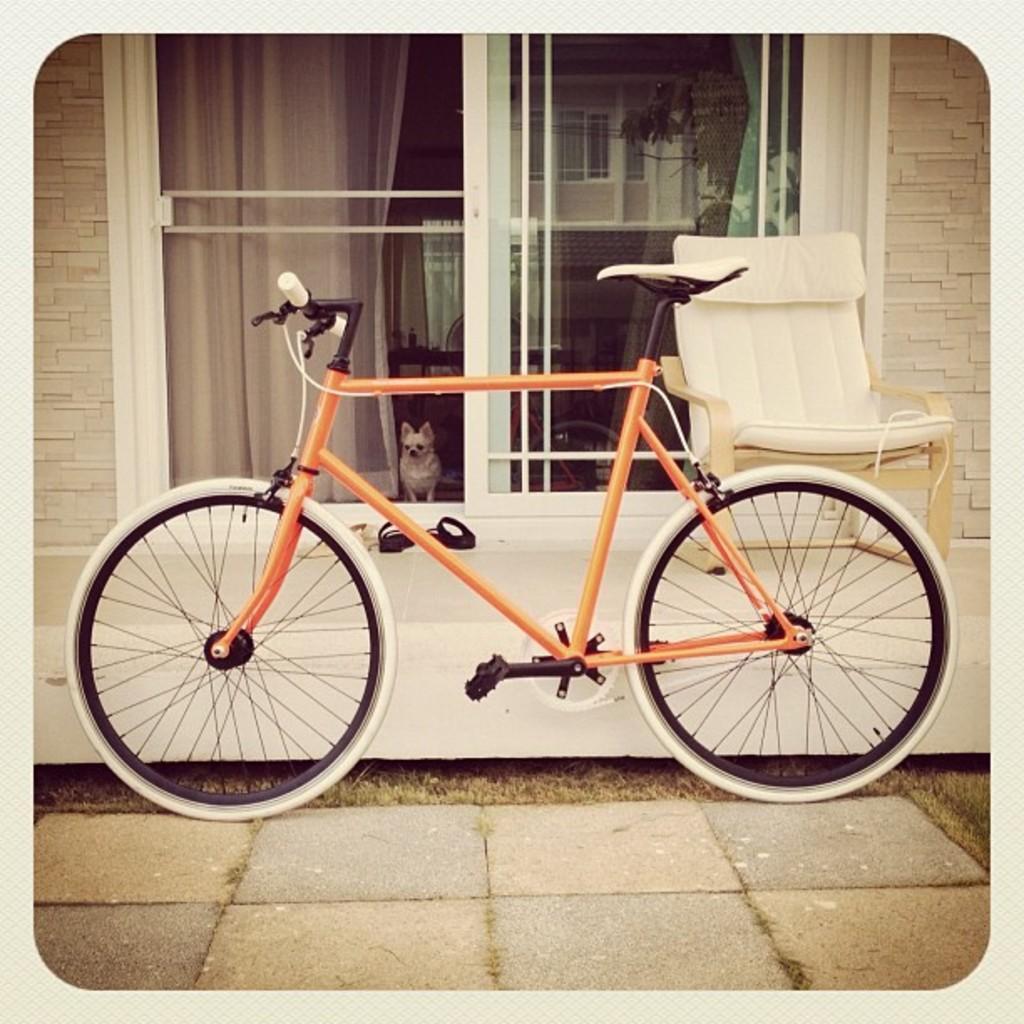Could you give a brief overview of what you see in this image? In this image we can see a bicycle placed on the ground. In the background, we can see a chair, door, a dog , group of shoes and the curtains. 